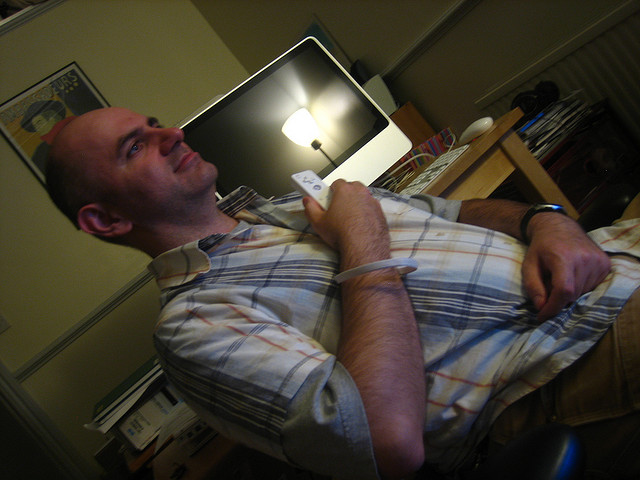<image>What program is on TV? It is ambiguous what program is on TV. It is not clear from the information given. What program is on TV? I don't know what program is on TV. It can be a show, nothing, or a wii game. 